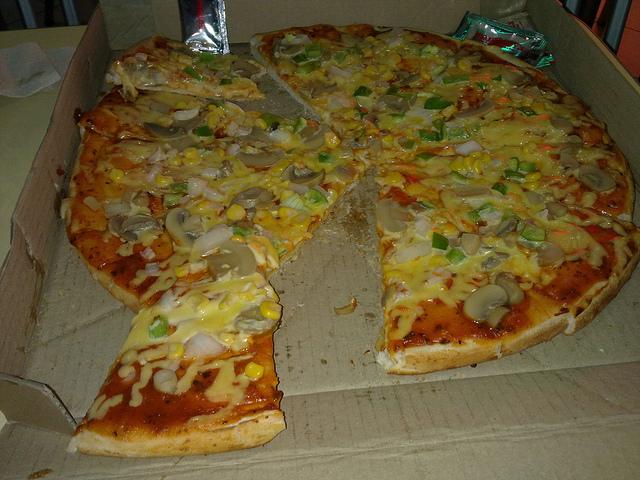Are these pizzas homemade?
Give a very brief answer. No. Has a slice been eaten?
Concise answer only. No. How many people can eat this pizza?
Quick response, please. 4. What shape are the slices?
Quick response, please. Triangle. Is there a raw herb on one of the pizzas?
Give a very brief answer. No. What is on the pizza?
Give a very brief answer. Cheese. Does that pizza have a thin crust?
Write a very short answer. Yes. Is the pizza homemade?
Give a very brief answer. No. What are the pizza's sitting on?
Short answer required. Box. How many slices of pizza are there?
Write a very short answer. 12. Does the pizza look appetizing?
Give a very brief answer. No. Is this pizza style Chicago or New York?
Be succinct. New york. Are there different types of pizza?
Keep it brief. No. What colors can be seen?
Answer briefly. Yellow. Is there meat on this pizza?
Give a very brief answer. No. How many slices of pizza is there?
Give a very brief answer. 12. Is this a homemade meal?
Be succinct. No. Has anyone started to eat the pizza?
Keep it brief. Yes. How many types of pizza are there?
Quick response, please. 1. What is the pizza being served on?
Give a very brief answer. Box. What shape is the pizza?
Concise answer only. Round. What is the pizza sitting on?
Quick response, please. Box. Is this a  large pizza?
Write a very short answer. Yes. What is the name for this pizza recipe?
Write a very short answer. Mushroom. Has the meal started?
Quick response, please. Yes. Is this cake sliced?
Keep it brief. Yes. What color is the cheese on this pizza?
Keep it brief. Yellow. How many slices is the pizza cut into?
Write a very short answer. 12. What is the pizza served on?
Write a very short answer. Box. Does this pizza look delicious?
Keep it brief. No. Has someone already been served?
Short answer required. Yes. Which slice of pizza is your favorite kind?
Write a very short answer. Cheese. How many pizzas are on the table?
Give a very brief answer. 1. Is this a normal looking pizza?
Give a very brief answer. Yes. Is this a normal shape for a pizza?
Concise answer only. Yes. 